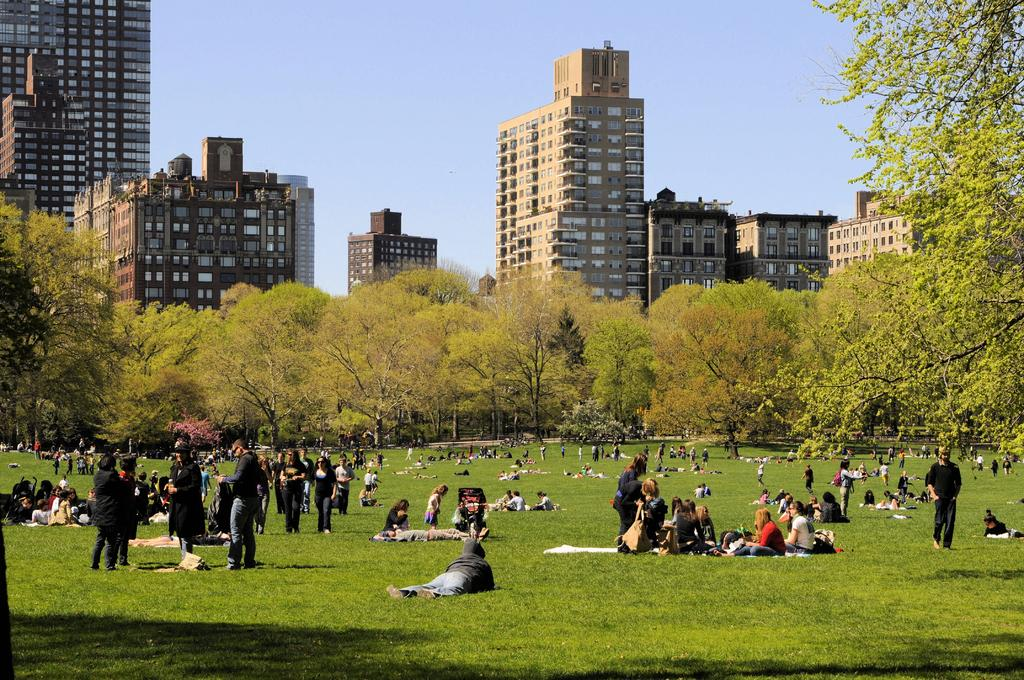How many people are in the image? There is a group of persons in the image, but the exact number cannot be determined from the provided facts. What is the terrain like where the group of persons is located? The group of persons is on a grassy land. What can be seen behind the group of persons? There is a group of trees and buildings visible behind the persons. What is visible at the top of the image? The sky is visible at the top of the image. What type of wire can be seen connecting the cellar to the slope in the image? There is no mention of a cellar, slope, or wire in the provided facts, so it cannot be determined if any such objects are present in the image. 